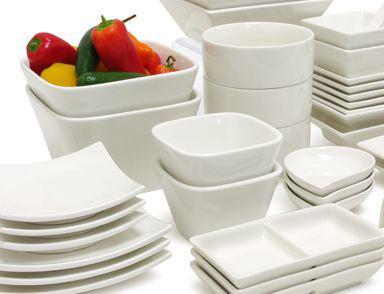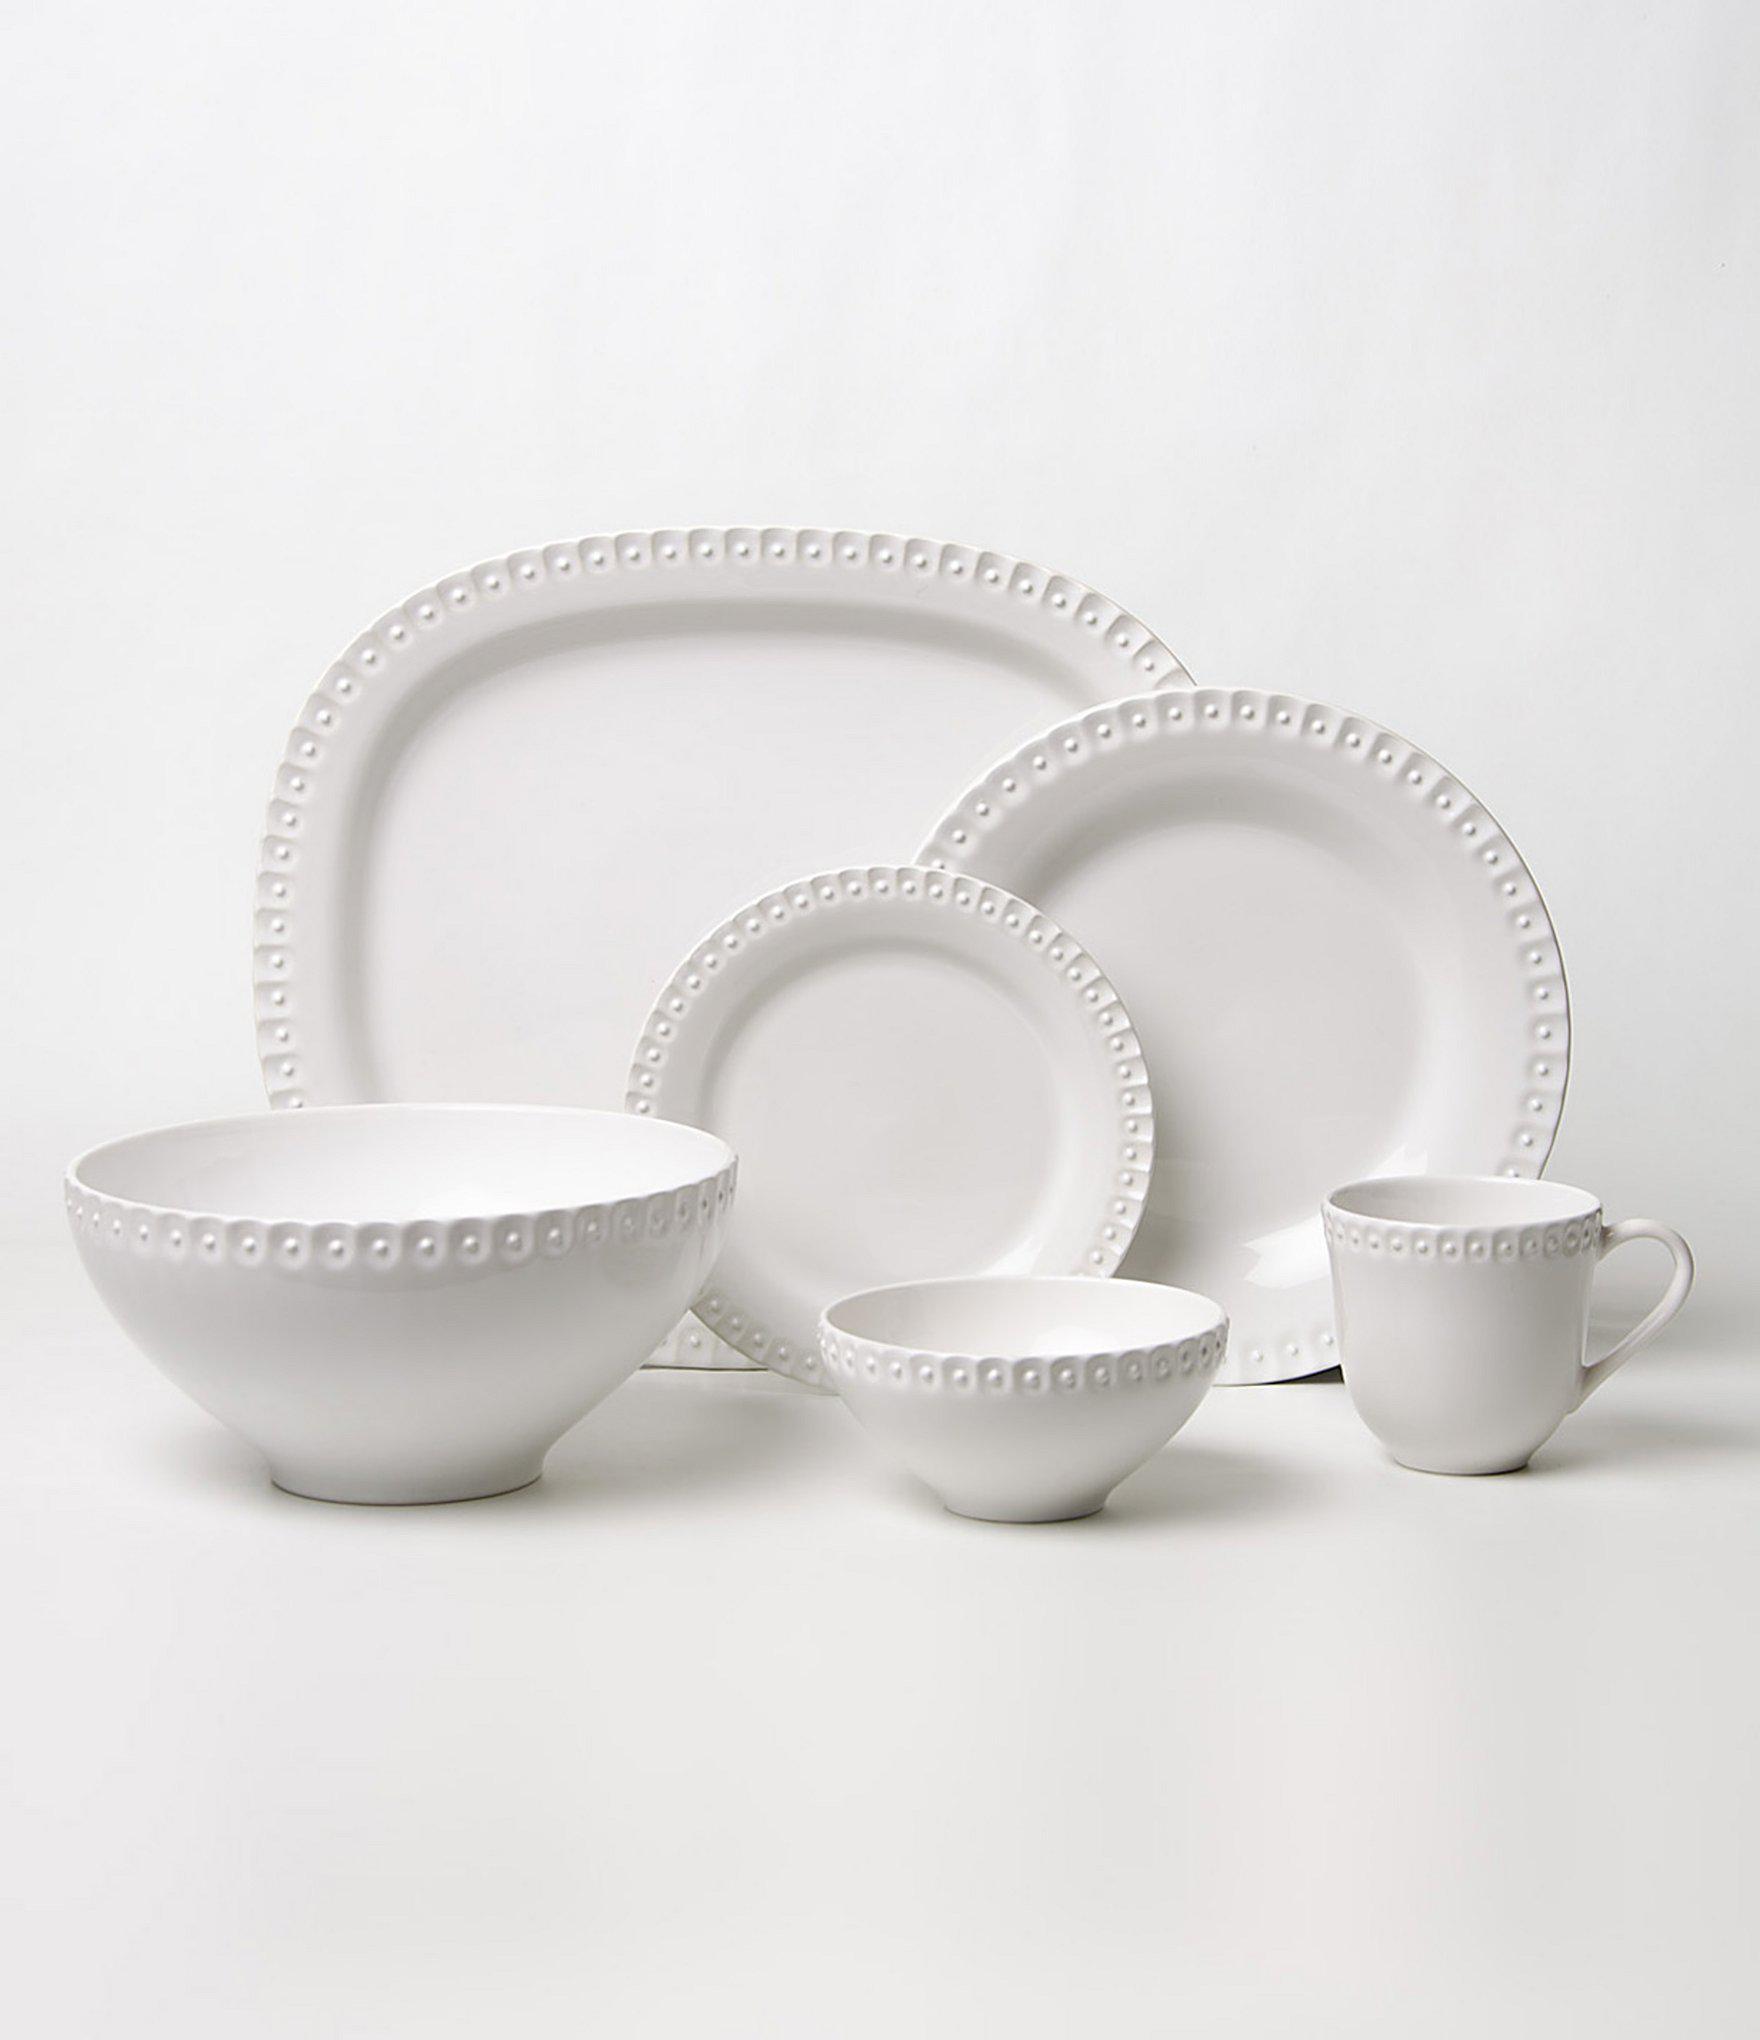The first image is the image on the left, the second image is the image on the right. Examine the images to the left and right. Is the description "There is all white dish with at least one thing green." accurate? Answer yes or no. Yes. The first image is the image on the left, the second image is the image on the right. Examine the images to the left and right. Is the description "There are plates stacked together in exactly one image." accurate? Answer yes or no. Yes. 